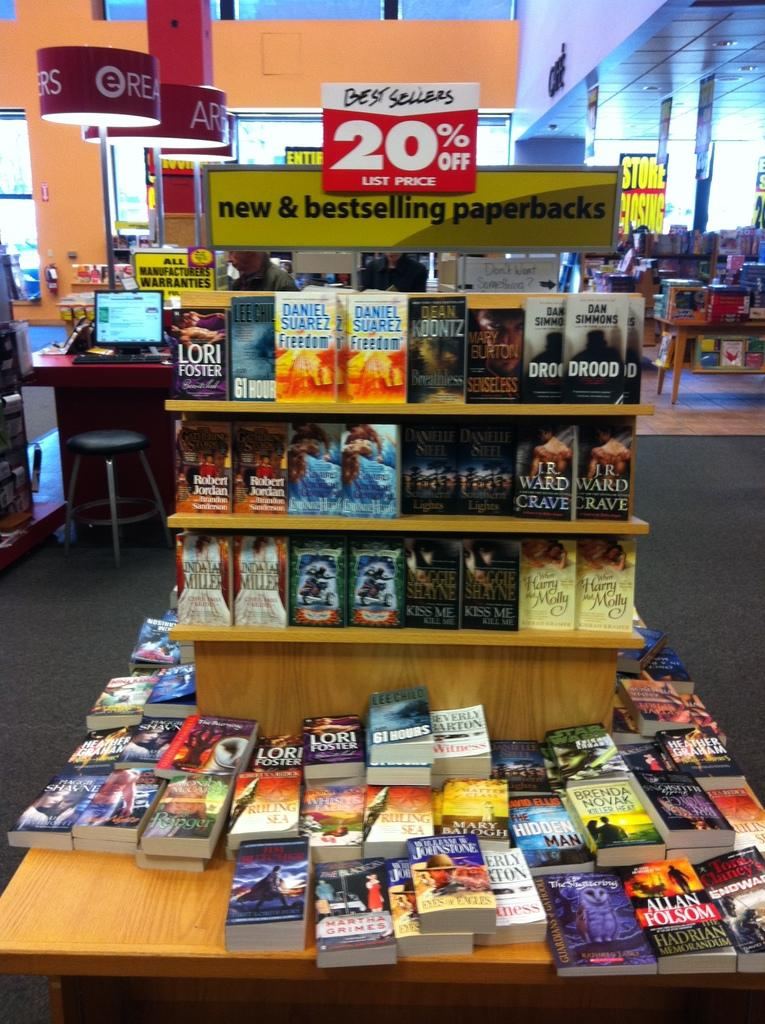<image>
Write a terse but informative summary of the picture. A display of book with a sign saying best sellers are 20% off list price 